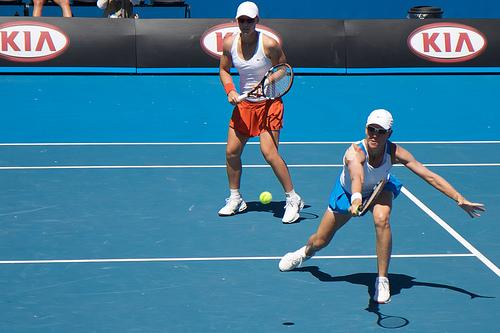List the primary accessories and clothing worn by the subjects in the image. White hat, orange wristband, sunglasses, white tank top, orange tennis skirt, blue tennis skirt, and white wristband. Explain the ongoing activity in the image and mention any brand logos visible. A tennis match between two players is taking place on a blue court, with a red Kia logo displayed on the wall. State the main focus of the image and any distinct features or clothing items the people are wearing. The main focus is on the two tennis players, one wearing a white hat and the other an orange wristband, as they engage in the match. Provide a brief summary of the scene displayed in the image. Two tennis players are engaged in a match on a blue tennis court, with one wearing a white hat and the other an orange wristband. Identify the primary colors and elements present in the image. The image features a blue tennis court, players wearing white and orange clothing, sunglasses, wristbands, hats, and a green tennis ball. Provide an overview of the image, emphasizing the sport, players, and their appearances. The image features a tennis match between two players showcasing unique personal styles, such as a white hat, orange wristband, and colorful outfits. Highlight the main objects present in the scene and their respective colors. Blue tennis court, two players wearing hats and wristbands, green tennis ball, white shoes and socks, and a red Kia logo on the wall. Describe the sports activity and outfits of the individuals involved in the image. Two tennis players are competing on a blue court, adorned with hats, wristbands, skirts, tank tops, shoes, and socks in various colors. Describe the environment and actions of the people in the picture. The image shows an intense tennis match taking place on a blue court, with players sporting various accessories such as hats and wristbands. Outline the setting and the main subjects involved in the image. The image is set on a blue tennis court, featuring two players engaged in a match, wearing distinct accessories like hats and wristbands. 